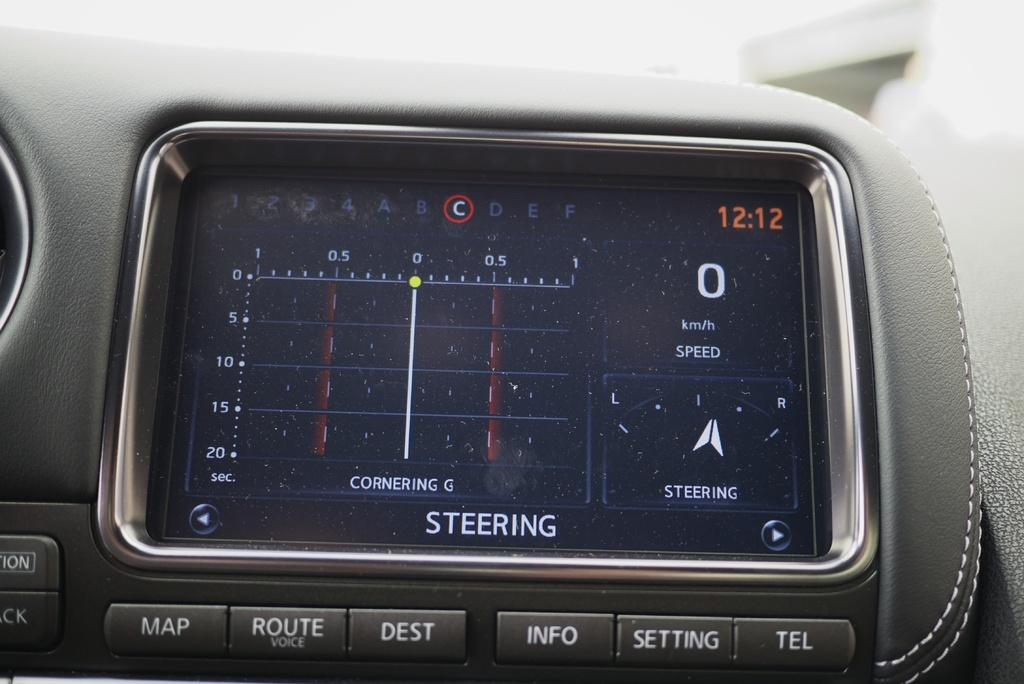<image>
Render a clear and concise summary of the photo. a screen on a car that says 'steering' at the bottom of it 